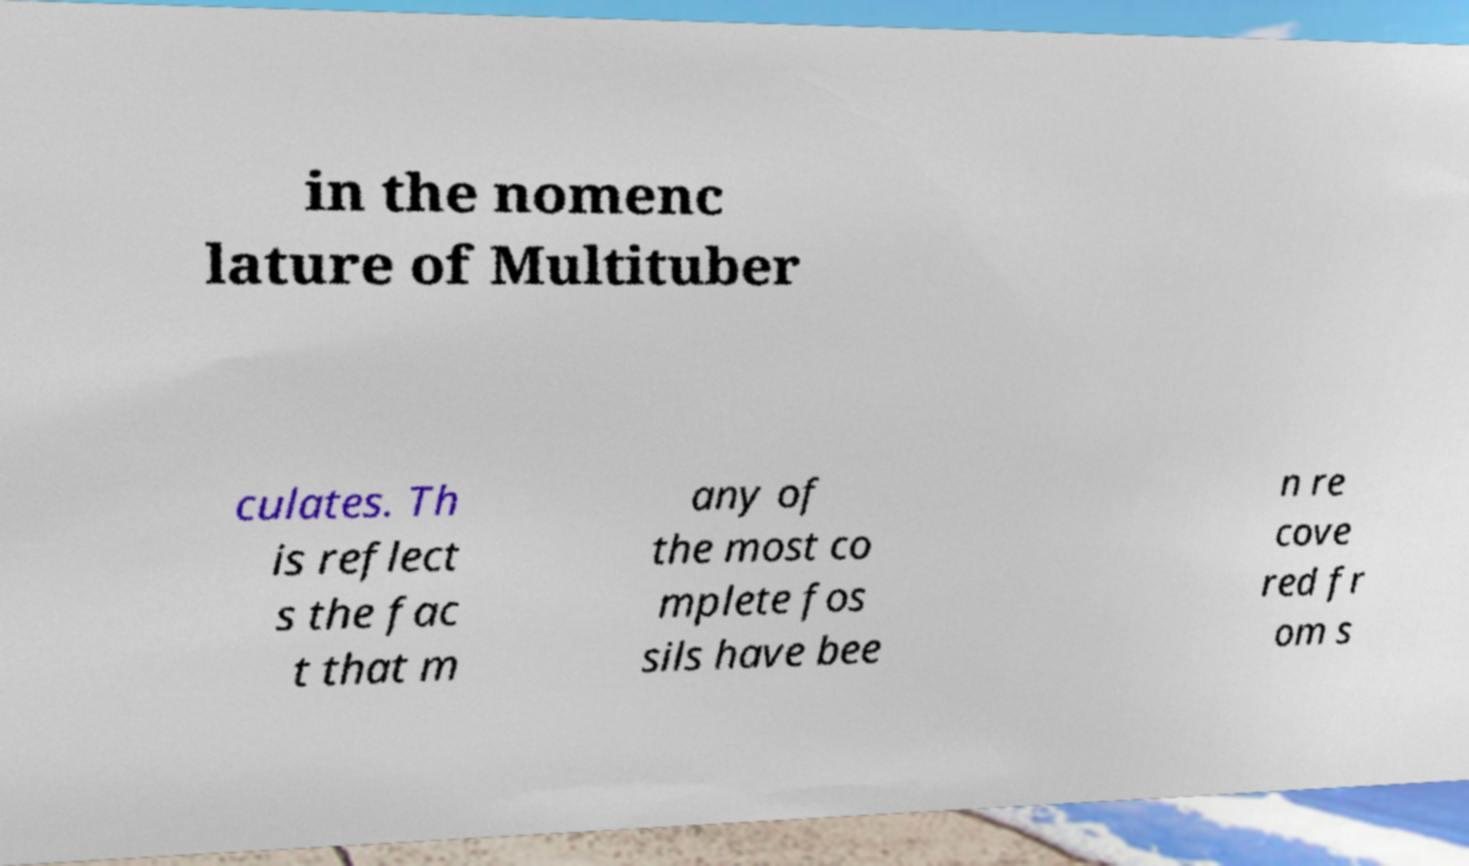For documentation purposes, I need the text within this image transcribed. Could you provide that? in the nomenc lature of Multituber culates. Th is reflect s the fac t that m any of the most co mplete fos sils have bee n re cove red fr om s 